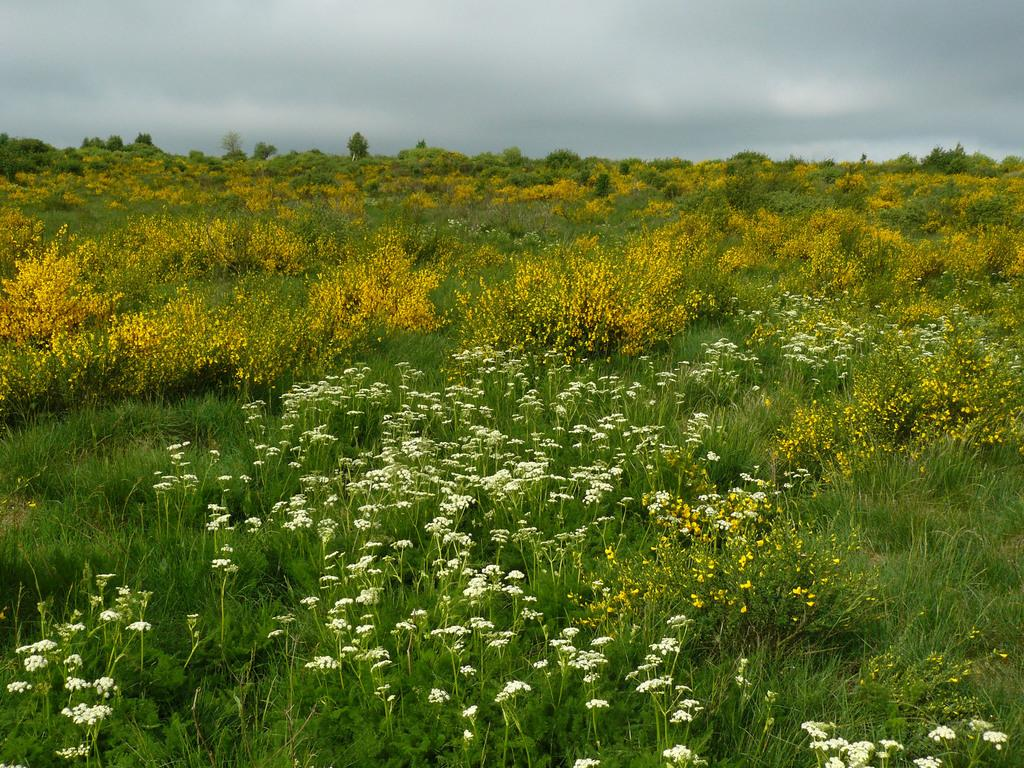What type of vegetation is present on the ground in the image? There is grass on the ground in the image. What other types of vegetation can be seen in the image? There are plants, flowers, and trees in the image. What is visible in the background of the image? The sky is visible in the image. What can be observed in the sky? There are clouds in the sky. What type of class is being held in the image? There is no class or any indication of a class being held in the image. 